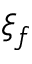<formula> <loc_0><loc_0><loc_500><loc_500>\xi _ { f }</formula> 